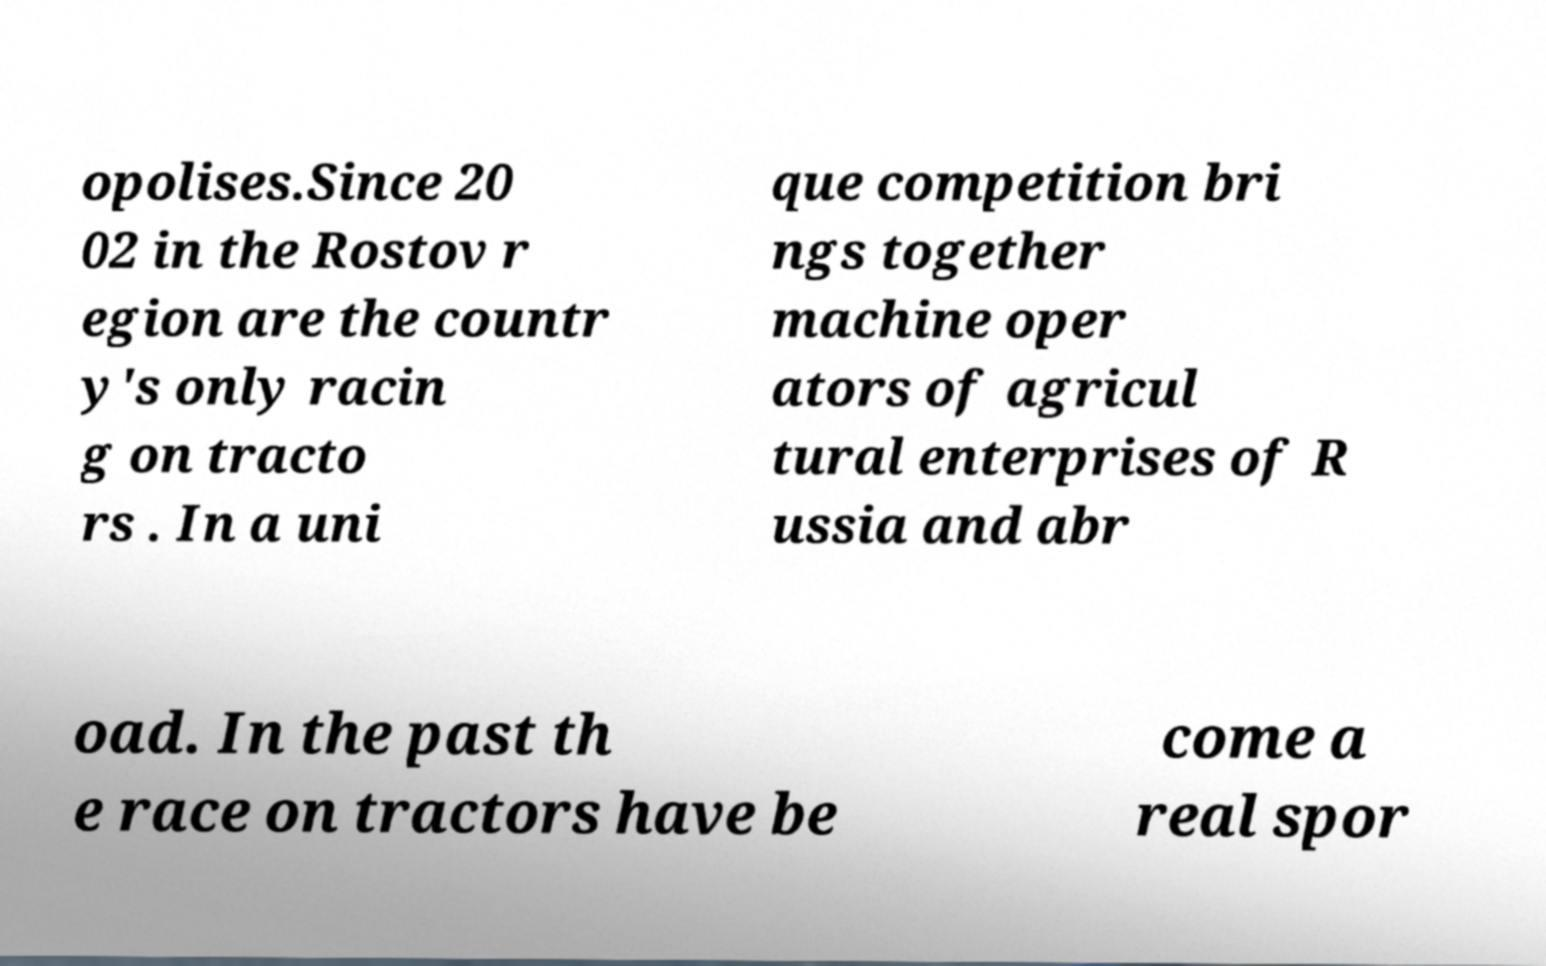What messages or text are displayed in this image? I need them in a readable, typed format. opolises.Since 20 02 in the Rostov r egion are the countr y's only racin g on tracto rs . In a uni que competition bri ngs together machine oper ators of agricul tural enterprises of R ussia and abr oad. In the past th e race on tractors have be come a real spor 